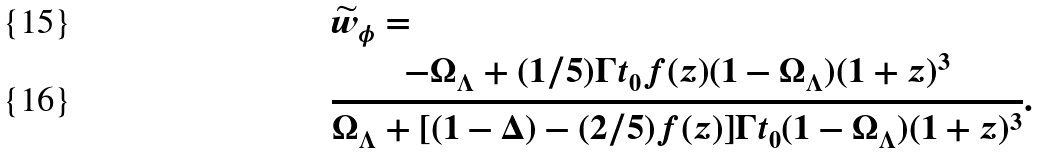<formula> <loc_0><loc_0><loc_500><loc_500>& \widetilde { w } _ { \phi } = \\ & \frac { - \Omega _ { \Lambda } + ( 1 / 5 ) \Gamma t _ { 0 } f ( z ) ( 1 - \Omega _ { \Lambda } ) ( 1 + z ) ^ { 3 } } { \Omega _ { \Lambda } + [ ( 1 - \Delta ) - ( 2 / 5 ) f ( z ) ] \Gamma t _ { 0 } ( 1 - \Omega _ { \Lambda } ) ( 1 + z ) ^ { 3 } } .</formula> 